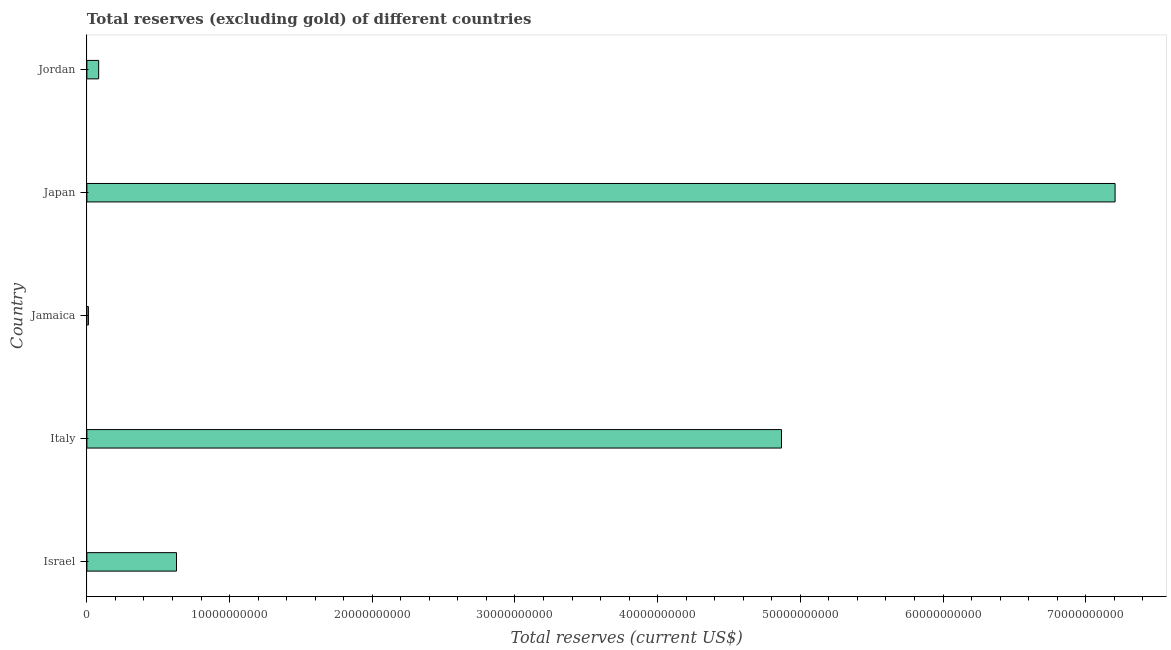Does the graph contain any zero values?
Ensure brevity in your answer.  No. Does the graph contain grids?
Give a very brief answer. No. What is the title of the graph?
Provide a short and direct response. Total reserves (excluding gold) of different countries. What is the label or title of the X-axis?
Offer a very short reply. Total reserves (current US$). What is the label or title of the Y-axis?
Offer a terse response. Country. What is the total reserves (excluding gold) in Jamaica?
Offer a very short reply. 1.06e+08. Across all countries, what is the maximum total reserves (excluding gold)?
Your answer should be compact. 7.21e+1. Across all countries, what is the minimum total reserves (excluding gold)?
Your answer should be compact. 1.06e+08. In which country was the total reserves (excluding gold) minimum?
Give a very brief answer. Jamaica. What is the sum of the total reserves (excluding gold)?
Offer a very short reply. 1.28e+11. What is the difference between the total reserves (excluding gold) in Israel and Jamaica?
Your answer should be compact. 6.17e+09. What is the average total reserves (excluding gold) per country?
Your answer should be compact. 2.56e+1. What is the median total reserves (excluding gold)?
Make the answer very short. 6.28e+09. What is the ratio of the total reserves (excluding gold) in Japan to that in Jordan?
Your answer should be compact. 87.26. Is the difference between the total reserves (excluding gold) in Italy and Jordan greater than the difference between any two countries?
Make the answer very short. No. What is the difference between the highest and the second highest total reserves (excluding gold)?
Make the answer very short. 2.34e+1. What is the difference between the highest and the lowest total reserves (excluding gold)?
Keep it short and to the point. 7.20e+1. In how many countries, is the total reserves (excluding gold) greater than the average total reserves (excluding gold) taken over all countries?
Offer a very short reply. 2. What is the Total reserves (current US$) in Israel?
Your answer should be very brief. 6.28e+09. What is the Total reserves (current US$) of Italy?
Keep it short and to the point. 4.87e+1. What is the Total reserves (current US$) in Jamaica?
Give a very brief answer. 1.06e+08. What is the Total reserves (current US$) of Japan?
Give a very brief answer. 7.21e+1. What is the Total reserves (current US$) of Jordan?
Give a very brief answer. 8.26e+08. What is the difference between the Total reserves (current US$) in Israel and Italy?
Keep it short and to the point. -4.24e+1. What is the difference between the Total reserves (current US$) in Israel and Jamaica?
Keep it short and to the point. 6.17e+09. What is the difference between the Total reserves (current US$) in Israel and Japan?
Ensure brevity in your answer.  -6.58e+1. What is the difference between the Total reserves (current US$) in Israel and Jordan?
Provide a short and direct response. 5.45e+09. What is the difference between the Total reserves (current US$) in Italy and Jamaica?
Provide a succinct answer. 4.86e+1. What is the difference between the Total reserves (current US$) in Italy and Japan?
Make the answer very short. -2.34e+1. What is the difference between the Total reserves (current US$) in Italy and Jordan?
Your response must be concise. 4.79e+1. What is the difference between the Total reserves (current US$) in Jamaica and Japan?
Ensure brevity in your answer.  -7.20e+1. What is the difference between the Total reserves (current US$) in Jamaica and Jordan?
Give a very brief answer. -7.20e+08. What is the difference between the Total reserves (current US$) in Japan and Jordan?
Make the answer very short. 7.12e+1. What is the ratio of the Total reserves (current US$) in Israel to that in Italy?
Make the answer very short. 0.13. What is the ratio of the Total reserves (current US$) in Israel to that in Jamaica?
Provide a succinct answer. 59.2. What is the ratio of the Total reserves (current US$) in Israel to that in Japan?
Your response must be concise. 0.09. What is the ratio of the Total reserves (current US$) in Israel to that in Jordan?
Offer a terse response. 7.6. What is the ratio of the Total reserves (current US$) in Italy to that in Jamaica?
Make the answer very short. 458.99. What is the ratio of the Total reserves (current US$) in Italy to that in Japan?
Give a very brief answer. 0.68. What is the ratio of the Total reserves (current US$) in Italy to that in Jordan?
Your answer should be compact. 58.95. What is the ratio of the Total reserves (current US$) in Jamaica to that in Japan?
Provide a short and direct response. 0. What is the ratio of the Total reserves (current US$) in Jamaica to that in Jordan?
Give a very brief answer. 0.13. What is the ratio of the Total reserves (current US$) in Japan to that in Jordan?
Your response must be concise. 87.26. 